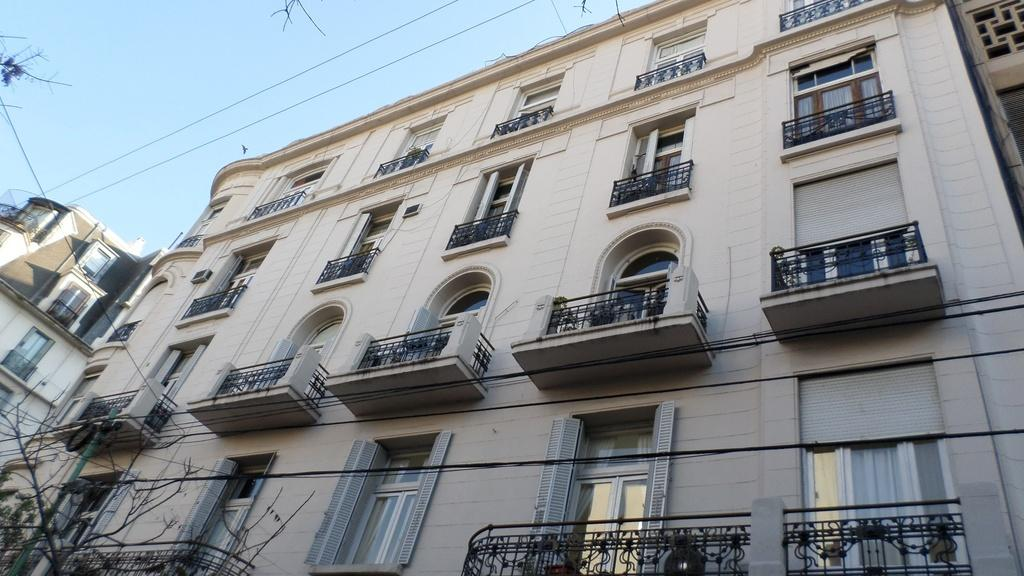What type of structures can be seen in the image? There are buildings in the image. What feature is present near the buildings? Railings are visible in the image. What can be seen in the background of the image? There are wires and the sky visible in the background of the image. What type of vegetation is present in the image? There are trees in the image. How many brothers are depicted in the image? There are no brothers present in the image; it features buildings, railings, wires, the sky, and trees. What rule is being enforced in the image? There is no rule being enforced in the image; it is a static scene of buildings, railings, wires, the sky, and trees. 